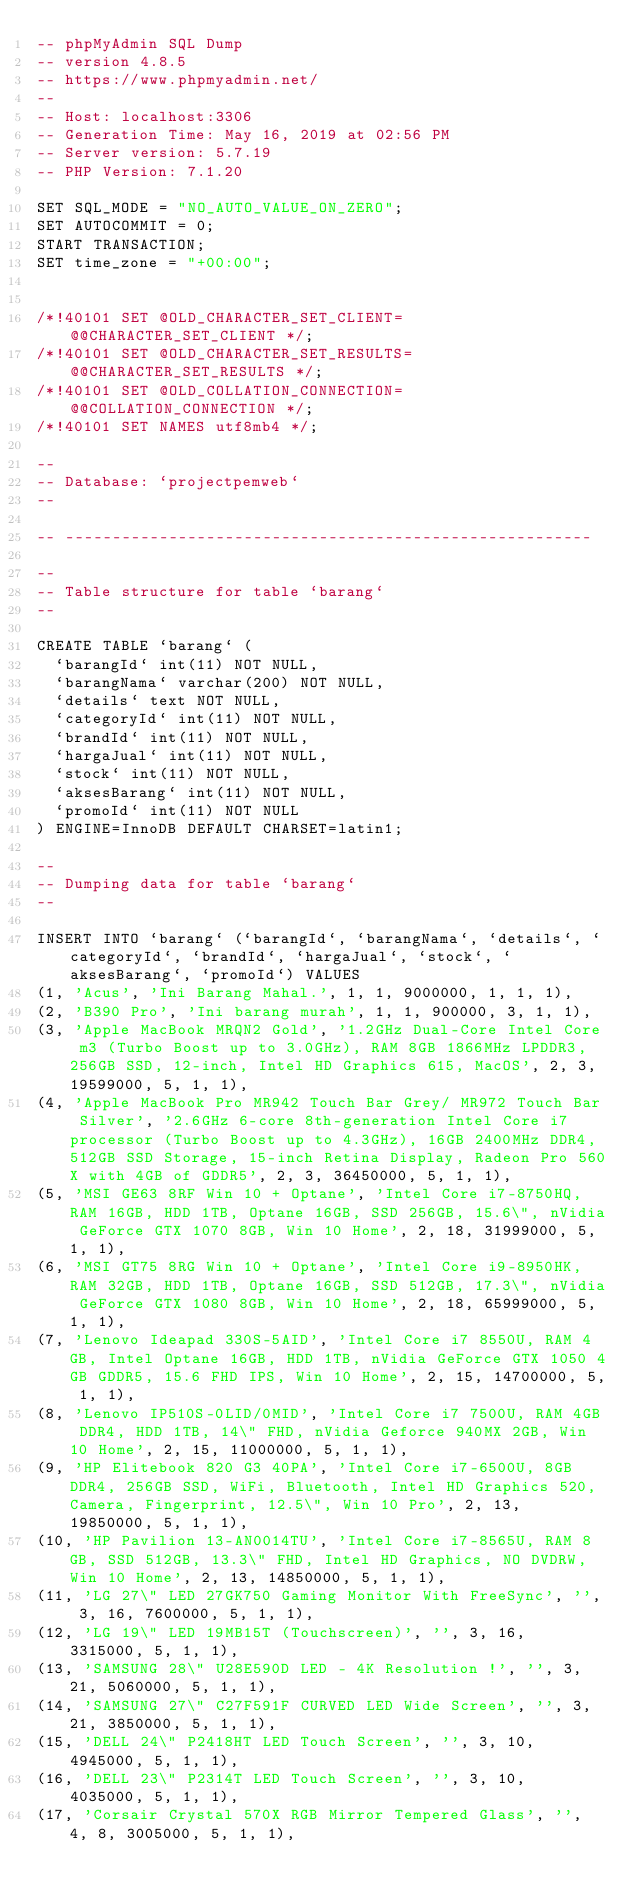<code> <loc_0><loc_0><loc_500><loc_500><_SQL_>-- phpMyAdmin SQL Dump
-- version 4.8.5
-- https://www.phpmyadmin.net/
--
-- Host: localhost:3306
-- Generation Time: May 16, 2019 at 02:56 PM
-- Server version: 5.7.19
-- PHP Version: 7.1.20

SET SQL_MODE = "NO_AUTO_VALUE_ON_ZERO";
SET AUTOCOMMIT = 0;
START TRANSACTION;
SET time_zone = "+00:00";


/*!40101 SET @OLD_CHARACTER_SET_CLIENT=@@CHARACTER_SET_CLIENT */;
/*!40101 SET @OLD_CHARACTER_SET_RESULTS=@@CHARACTER_SET_RESULTS */;
/*!40101 SET @OLD_COLLATION_CONNECTION=@@COLLATION_CONNECTION */;
/*!40101 SET NAMES utf8mb4 */;

--
-- Database: `projectpemweb`
--

-- --------------------------------------------------------

--
-- Table structure for table `barang`
--

CREATE TABLE `barang` (
  `barangId` int(11) NOT NULL,
  `barangNama` varchar(200) NOT NULL,
  `details` text NOT NULL,
  `categoryId` int(11) NOT NULL,
  `brandId` int(11) NOT NULL,
  `hargaJual` int(11) NOT NULL,
  `stock` int(11) NOT NULL,
  `aksesBarang` int(11) NOT NULL,
  `promoId` int(11) NOT NULL
) ENGINE=InnoDB DEFAULT CHARSET=latin1;

--
-- Dumping data for table `barang`
--

INSERT INTO `barang` (`barangId`, `barangNama`, `details`, `categoryId`, `brandId`, `hargaJual`, `stock`, `aksesBarang`, `promoId`) VALUES
(1, 'Acus', 'Ini Barang Mahal.', 1, 1, 9000000, 1, 1, 1),
(2, 'B390 Pro', 'Ini barang murah', 1, 1, 900000, 3, 1, 1),
(3, 'Apple MacBook MRQN2 Gold', '1.2GHz Dual-Core Intel Core m3 (Turbo Boost up to 3.0GHz), RAM 8GB 1866MHz LPDDR3, 256GB SSD, 12-inch, Intel HD Graphics 615, MacOS', 2, 3, 19599000, 5, 1, 1),
(4, 'Apple MacBook Pro MR942 Touch Bar Grey/ MR972 Touch Bar Silver', '2.6GHz 6-core 8th-generation Intel Core i7 processor (Turbo Boost up to 4.3GHz), 16GB 2400MHz DDR4, 512GB SSD Storage, 15-inch Retina Display, Radeon Pro 560X with 4GB of GDDR5', 2, 3, 36450000, 5, 1, 1),
(5, 'MSI GE63 8RF Win 10 + Optane', 'Intel Core i7-8750HQ, RAM 16GB, HDD 1TB, Optane 16GB, SSD 256GB, 15.6\", nVidia GeForce GTX 1070 8GB, Win 10 Home', 2, 18, 31999000, 5, 1, 1),
(6, 'MSI GT75 8RG Win 10 + Optane', 'Intel Core i9-8950HK, RAM 32GB, HDD 1TB, Optane 16GB, SSD 512GB, 17.3\", nVidia GeForce GTX 1080 8GB, Win 10 Home', 2, 18, 65999000, 5, 1, 1),
(7, 'Lenovo Ideapad 330S-5AID', 'Intel Core i7 8550U, RAM 4GB, Intel Optane 16GB, HDD 1TB, nVidia GeForce GTX 1050 4GB GDDR5, 15.6 FHD IPS, Win 10 Home', 2, 15, 14700000, 5, 1, 1),
(8, 'Lenovo IP510S-0LID/0MID', 'Intel Core i7 7500U, RAM 4GB DDR4, HDD 1TB, 14\" FHD, nVidia Geforce 940MX 2GB, Win 10 Home', 2, 15, 11000000, 5, 1, 1),
(9, 'HP Elitebook 820 G3 40PA', 'Intel Core i7-6500U, 8GB DDR4, 256GB SSD, WiFi, Bluetooth, Intel HD Graphics 520, Camera, Fingerprint, 12.5\", Win 10 Pro', 2, 13, 19850000, 5, 1, 1),
(10, 'HP Pavilion 13-AN0014TU', 'Intel Core i7-8565U, RAM 8GB, SSD 512GB, 13.3\" FHD, Intel HD Graphics, NO DVDRW, Win 10 Home', 2, 13, 14850000, 5, 1, 1),
(11, 'LG 27\" LED 27GK750 Gaming Monitor With FreeSync', '', 3, 16, 7600000, 5, 1, 1),
(12, 'LG 19\" LED 19MB15T (Touchscreen)', '', 3, 16, 3315000, 5, 1, 1),
(13, 'SAMSUNG 28\" U28E590D LED - 4K Resolution !', '', 3, 21, 5060000, 5, 1, 1),
(14, 'SAMSUNG 27\" C27F591F CURVED LED Wide Screen', '', 3, 21, 3850000, 5, 1, 1),
(15, 'DELL 24\" P2418HT LED Touch Screen', '', 3, 10, 4945000, 5, 1, 1),
(16, 'DELL 23\" P2314T LED Touch Screen', '', 3, 10, 4035000, 5, 1, 1),
(17, 'Corsair Crystal 570X RGB Mirror Tempered Glass', '', 4, 8, 3005000, 5, 1, 1),</code> 